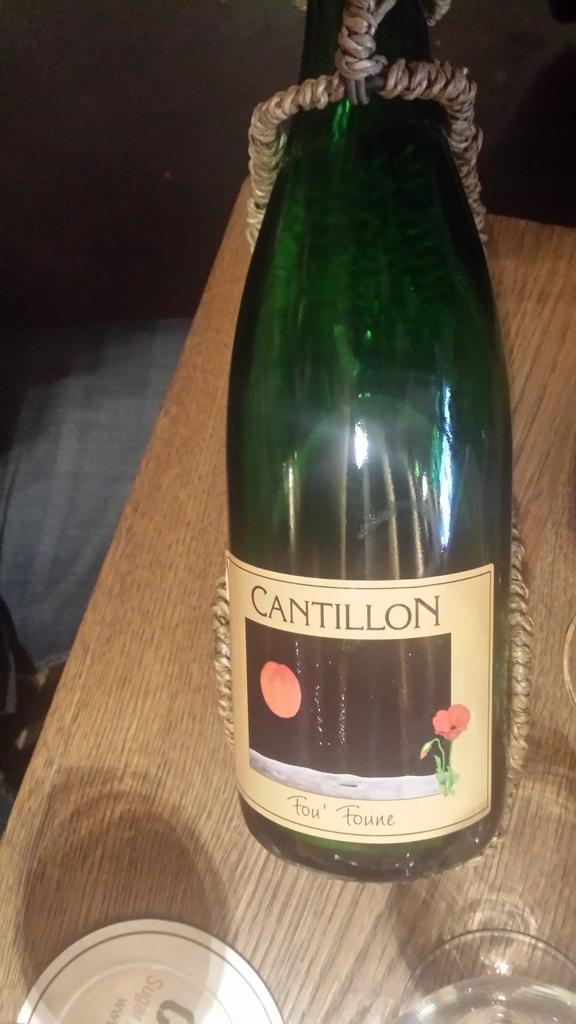<image>
Present a compact description of the photo's key features. A tall bottle of Cantillon wine sits on a wooden surface. 